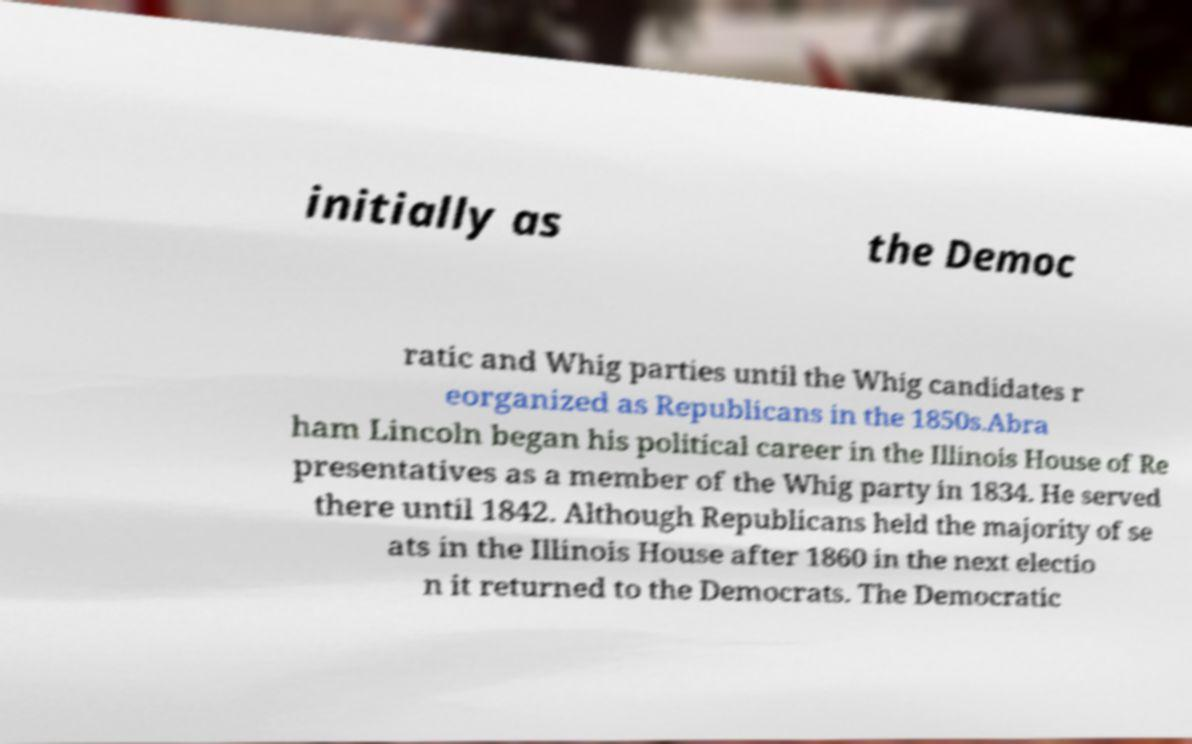Could you extract and type out the text from this image? initially as the Democ ratic and Whig parties until the Whig candidates r eorganized as Republicans in the 1850s.Abra ham Lincoln began his political career in the Illinois House of Re presentatives as a member of the Whig party in 1834. He served there until 1842. Although Republicans held the majority of se ats in the Illinois House after 1860 in the next electio n it returned to the Democrats. The Democratic 